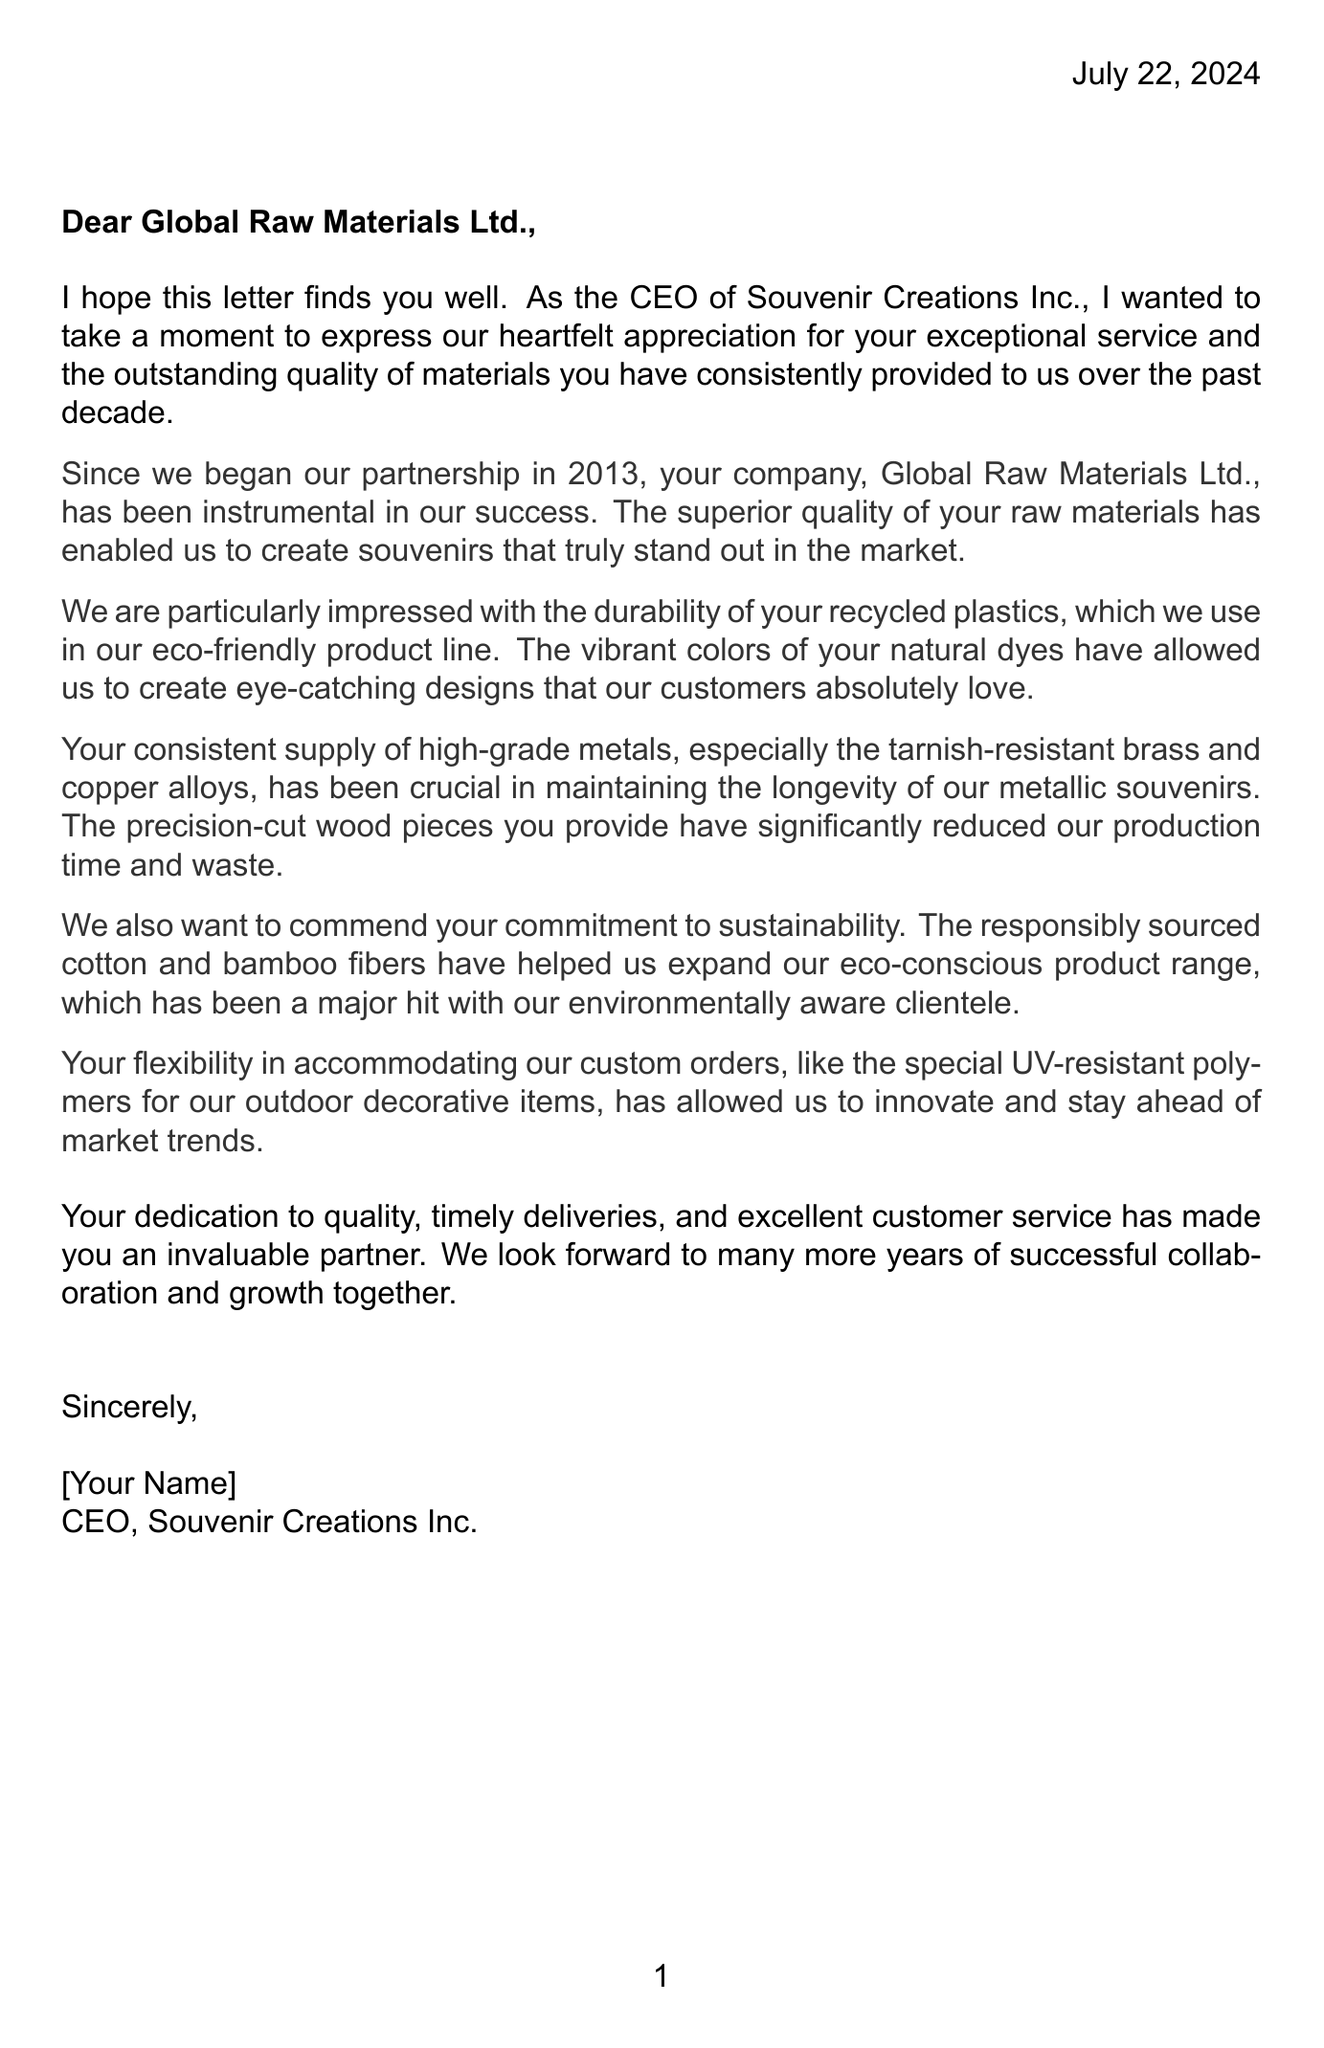What is the name of the client company? The client company is identified at the beginning of the document, which is Souvenir Creations Inc.
Answer: Souvenir Creations Inc How many years has the partnership lasted? The letter mentions that the partnership has been ongoing since 2013, which totals ten years.
Answer: 10 What materials are praised for their durability? The letter specifically mentions the recycled plastics used in the eco-friendly product line as durable materials.
Answer: Recycled plastics What type of dyes does the client use? It is stated in the letter that the client uses natural dyes for their designs.
Answer: Natural dyes What is the location of the client company? The letter refers to the location of the client company as Orlando, Florida.
Answer: Orlando, Florida What is a key strength of Global Raw Materials Ltd.? The letter indicates several strengths of Global Raw Materials Ltd., including the focus on sustainability.
Answer: Sustainability focus What commitment is commended in the letter? The client praises the supplier's commitment to sustainability regarding their materials used.
Answer: Commitment to sustainability What type of polymers were accommodated in custom orders? The letter mentions that UV-resistant polymers were provided for custom orders.
Answer: UV-resistant polymers Who is the author of the letter? The closing of the letter reveals that it is written by the CEO of Souvenir Creations Inc., who signs off with [Your Name].
Answer: [Your Name] 